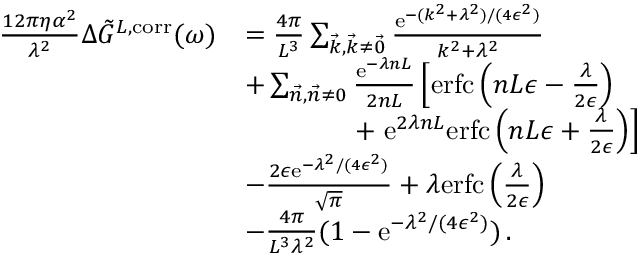<formula> <loc_0><loc_0><loc_500><loc_500>\begin{array} { r l } { \frac { 1 2 \pi \eta \alpha ^ { 2 } } { \lambda ^ { 2 } } \Delta \tilde { G } ^ { L , c o r r } ( \omega ) } & { = \frac { 4 \pi } { L ^ { 3 } } \sum _ { \vec { k } , \vec { k } \neq \vec { 0 } } \frac { e ^ { - ( k ^ { 2 } + \lambda ^ { 2 } ) / ( 4 \epsilon ^ { 2 } ) } } { k ^ { 2 } + \lambda ^ { 2 } } } \\ & { + \sum _ { \vec { n } , \vec { n } \neq 0 } \frac { e ^ { - \lambda n L } } { 2 n L } \left [ e r f c \left ( n L \epsilon - \frac { \lambda } { 2 \epsilon } \right ) } \\ & { \quad + e ^ { 2 \lambda n L } e r f c \left ( n L \epsilon + \frac { \lambda } { 2 \epsilon } \right ) \right ] } \\ & { - \frac { 2 \epsilon e ^ { - \lambda ^ { 2 } / ( 4 \epsilon ^ { 2 } ) } } { \sqrt { \pi } } + \lambda e r f c \left ( \frac { \lambda } { 2 \epsilon } \right ) } \\ & { - \frac { 4 \pi } { L ^ { 3 } \lambda ^ { 2 } } ( 1 - e ^ { - \lambda ^ { 2 } / ( 4 \epsilon ^ { 2 } ) } ) \, . } \end{array}</formula> 